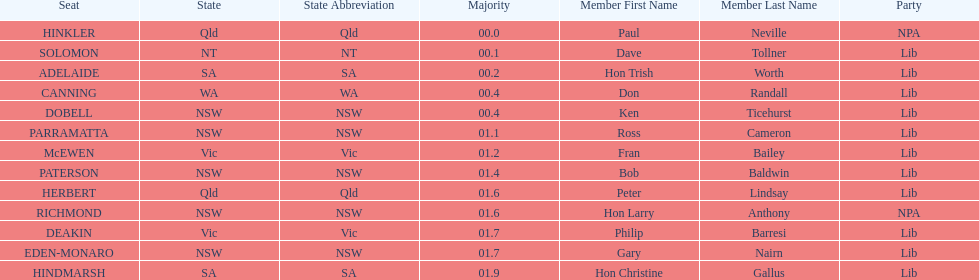Could you parse the entire table? {'header': ['Seat', 'State', 'State Abbreviation', 'Majority', 'Member First Name', 'Member Last Name', 'Party'], 'rows': [['HINKLER', 'Qld', 'Qld', '00.0', 'Paul', 'Neville', 'NPA'], ['SOLOMON', 'NT', 'NT', '00.1', 'Dave', 'Tollner', 'Lib'], ['ADELAIDE', 'SA', 'SA', '00.2', 'Hon Trish', 'Worth', 'Lib'], ['CANNING', 'WA', 'WA', '00.4', 'Don', 'Randall', 'Lib'], ['DOBELL', 'NSW', 'NSW', '00.4', 'Ken', 'Ticehurst', 'Lib'], ['PARRAMATTA', 'NSW', 'NSW', '01.1', 'Ross', 'Cameron', 'Lib'], ['McEWEN', 'Vic', 'Vic', '01.2', 'Fran', 'Bailey', 'Lib'], ['PATERSON', 'NSW', 'NSW', '01.4', 'Bob', 'Baldwin', 'Lib'], ['HERBERT', 'Qld', 'Qld', '01.6', 'Peter', 'Lindsay', 'Lib'], ['RICHMOND', 'NSW', 'NSW', '01.6', 'Hon Larry', 'Anthony', 'NPA'], ['DEAKIN', 'Vic', 'Vic', '01.7', 'Philip', 'Barresi', 'Lib'], ['EDEN-MONARO', 'NSW', 'NSW', '01.7', 'Gary', 'Nairn', 'Lib'], ['HINDMARSH', 'SA', 'SA', '01.9', 'Hon Christine', 'Gallus', 'Lib']]} What member comes next after hon trish worth? Don Randall. 